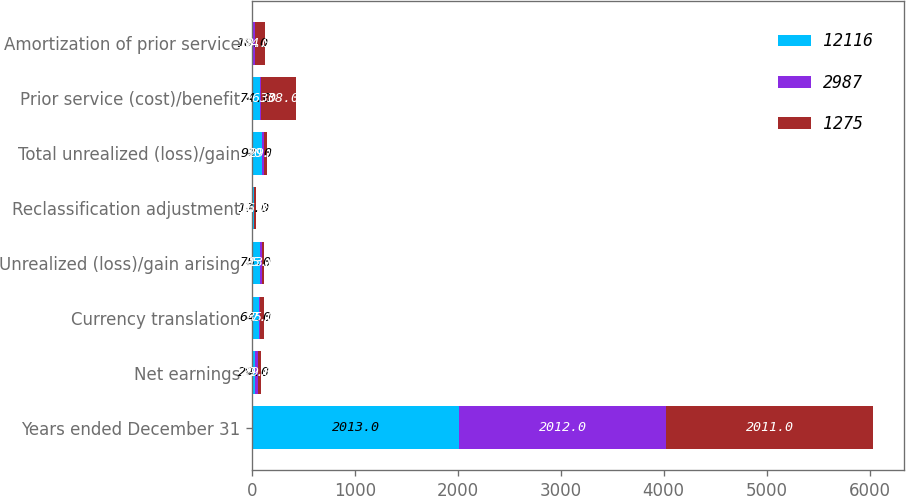Convert chart to OTSL. <chart><loc_0><loc_0><loc_500><loc_500><stacked_bar_chart><ecel><fcel>Years ended December 31<fcel>Net earnings<fcel>Currency translation<fcel>Unrealized (loss)/gain arising<fcel>Reclassification adjustment<fcel>Total unrealized (loss)/gain<fcel>Prior service (cost)/benefit<fcel>Amortization of prior service<nl><fcel>12116<fcel>2013<fcel>29<fcel>64<fcel>75<fcel>17<fcel>92<fcel>74<fcel>10<nl><fcel>2987<fcel>2012<fcel>29<fcel>17<fcel>25<fcel>5<fcel>20<fcel>16<fcel>18<nl><fcel>1275<fcel>2011<fcel>29<fcel>35<fcel>13<fcel>16<fcel>29<fcel>338<fcel>94<nl></chart> 